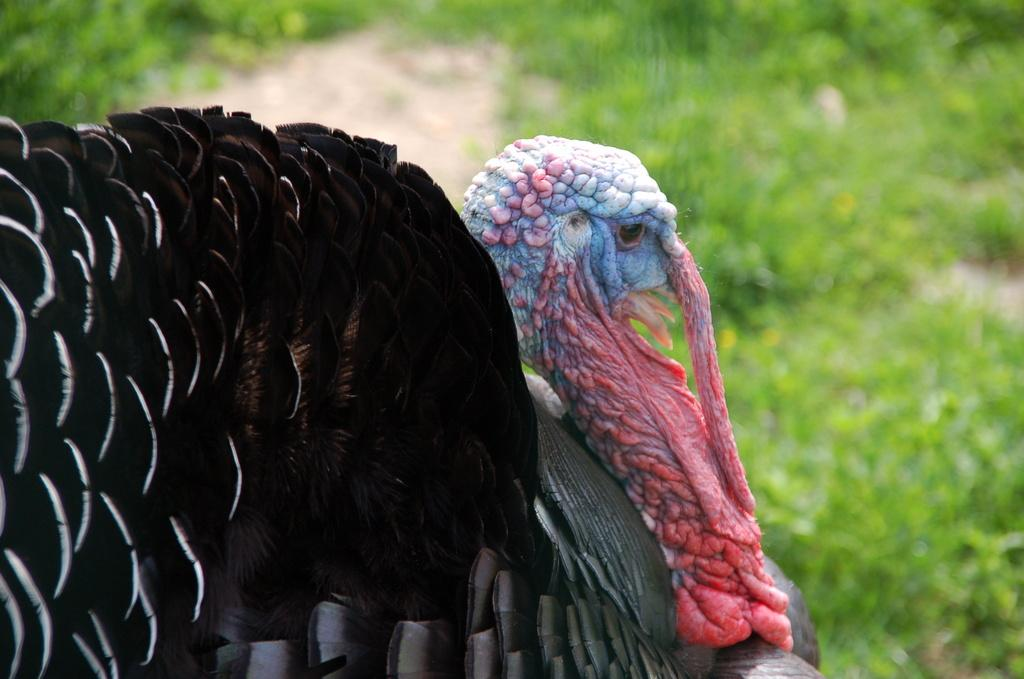What animal is the main subject of the image? There is a turkey bird in the front of the image. What can be seen in the background of the image? There are plants in the background of the image. How would you describe the appearance of the background? The background appears blurry. What type of memory is being used to store the image? The question about memory is not relevant to the image, as it focuses on the storage of the image rather than its content. 